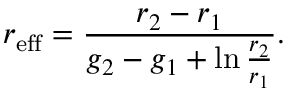<formula> <loc_0><loc_0><loc_500><loc_500>r _ { e f f } = \frac { r _ { 2 } - r _ { 1 } } { g _ { 2 } - g _ { 1 } + \ln \frac { r _ { 2 } } { r _ { 1 } } } .</formula> 